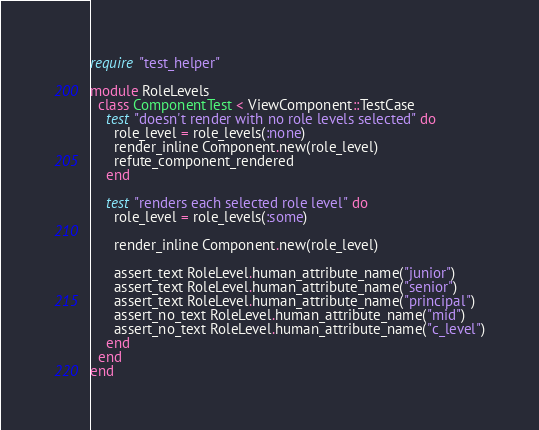Convert code to text. <code><loc_0><loc_0><loc_500><loc_500><_Ruby_>require "test_helper"

module RoleLevels
  class ComponentTest < ViewComponent::TestCase
    test "doesn't render with no role levels selected" do
      role_level = role_levels(:none)
      render_inline Component.new(role_level)
      refute_component_rendered
    end

    test "renders each selected role level" do
      role_level = role_levels(:some)

      render_inline Component.new(role_level)

      assert_text RoleLevel.human_attribute_name("junior")
      assert_text RoleLevel.human_attribute_name("senior")
      assert_text RoleLevel.human_attribute_name("principal")
      assert_no_text RoleLevel.human_attribute_name("mid")
      assert_no_text RoleLevel.human_attribute_name("c_level")
    end
  end
end
</code> 